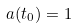Convert formula to latex. <formula><loc_0><loc_0><loc_500><loc_500>a ( t _ { 0 } ) = 1</formula> 